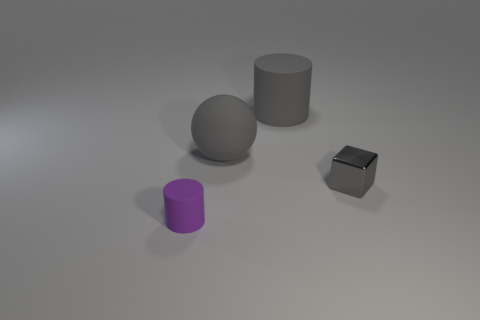Do the matte sphere and the cylinder behind the purple object have the same color?
Offer a terse response. Yes. What is the material of the purple cylinder that is the same size as the gray metal cube?
Offer a very short reply. Rubber. Is there a big purple sphere that has the same material as the gray cylinder?
Make the answer very short. No. What number of big gray things are there?
Ensure brevity in your answer.  2. Do the gray cube and the cylinder behind the small purple rubber object have the same material?
Give a very brief answer. No. What material is the big cylinder that is the same color as the tiny block?
Ensure brevity in your answer.  Rubber. How many metal things have the same color as the tiny rubber object?
Your answer should be compact. 0. What size is the purple thing?
Keep it short and to the point. Small. Does the small gray metallic thing have the same shape as the object that is in front of the tiny block?
Give a very brief answer. No. The tiny thing that is the same material as the gray ball is what color?
Provide a short and direct response. Purple. 